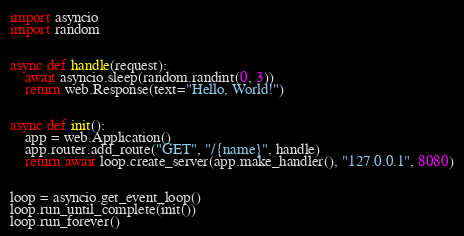<code> <loc_0><loc_0><loc_500><loc_500><_Python_>import asyncio
import random


async def handle(request):
    await asyncio.sleep(random.randint(0, 3))
    return web.Response(text="Hello, World!")


async def init():
    app = web.Application()
    app.router.add_route("GET", "/{name}", handle)
    return await loop.create_server(app.make_handler(), "127.0.0.1", 8080)


loop = asyncio.get_event_loop()
loop.run_until_complete(init())
loop.run_forever()
</code> 